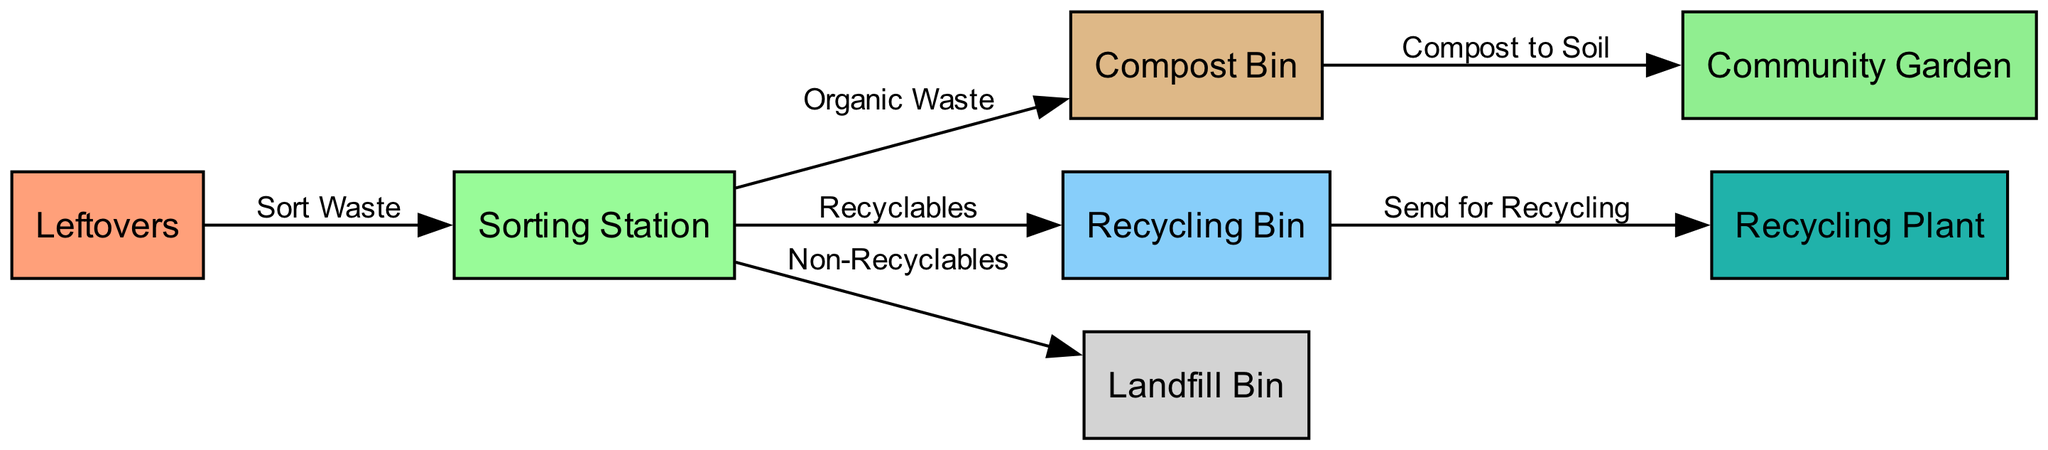What is the first step in the waste management process? The diagram shows that the first node in the process is "Leftovers," which is where the waste originates before it goes to the sorting station.
Answer: Leftovers How many nodes are depicted in the diagram? By counting the nodes listed in the diagram, there are seven: leftovers, sorting station, compost bin, recycling bin, landfill bin, community garden, and recycling plant.
Answer: 7 What type of waste goes from the sorting station to the compost bin? The edge labeled "Organic Waste" indicates that organic waste is the type of waste that moves from the sorting station to the compost bin.
Answer: Organic Waste Which bin receives non-recyclable waste? The diagram shows a connection from the sorting station to the landfill bin labeled "Non-Recyclables," indicating that non-recyclable waste goes there.
Answer: Landfill Bin What happens to compost from the compost bin? The compost created in the compost bin is directed to the community garden as indicated in the edge labeled "Compost to Soil."
Answer: Community Garden How many edges are in the diagram? By examining the edges listed, we find there are six connections: three to bins (compost, recycling, landfill) and two outgoing from those bins, making a total of six.
Answer: 6 What does the recycling bin send for? The recycling bin is connected to the recycling plant with an edge labeled "Send for Recycling," indicating that it sends recyclable materials there.
Answer: Send for Recycling What is the connection between the compost bin and the community garden? The diagram indicates that the relationship between the compost bin and the community garden is that compost is used to enrich the soil in the garden as described by the label "Compost to Soil."
Answer: Compost to Soil Which node indicates where sorting takes place? The "Sorting Station" is the node in the diagram that represents the location where waste is sorted into different categories.
Answer: Sorting Station 